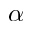<formula> <loc_0><loc_0><loc_500><loc_500>\alpha</formula> 